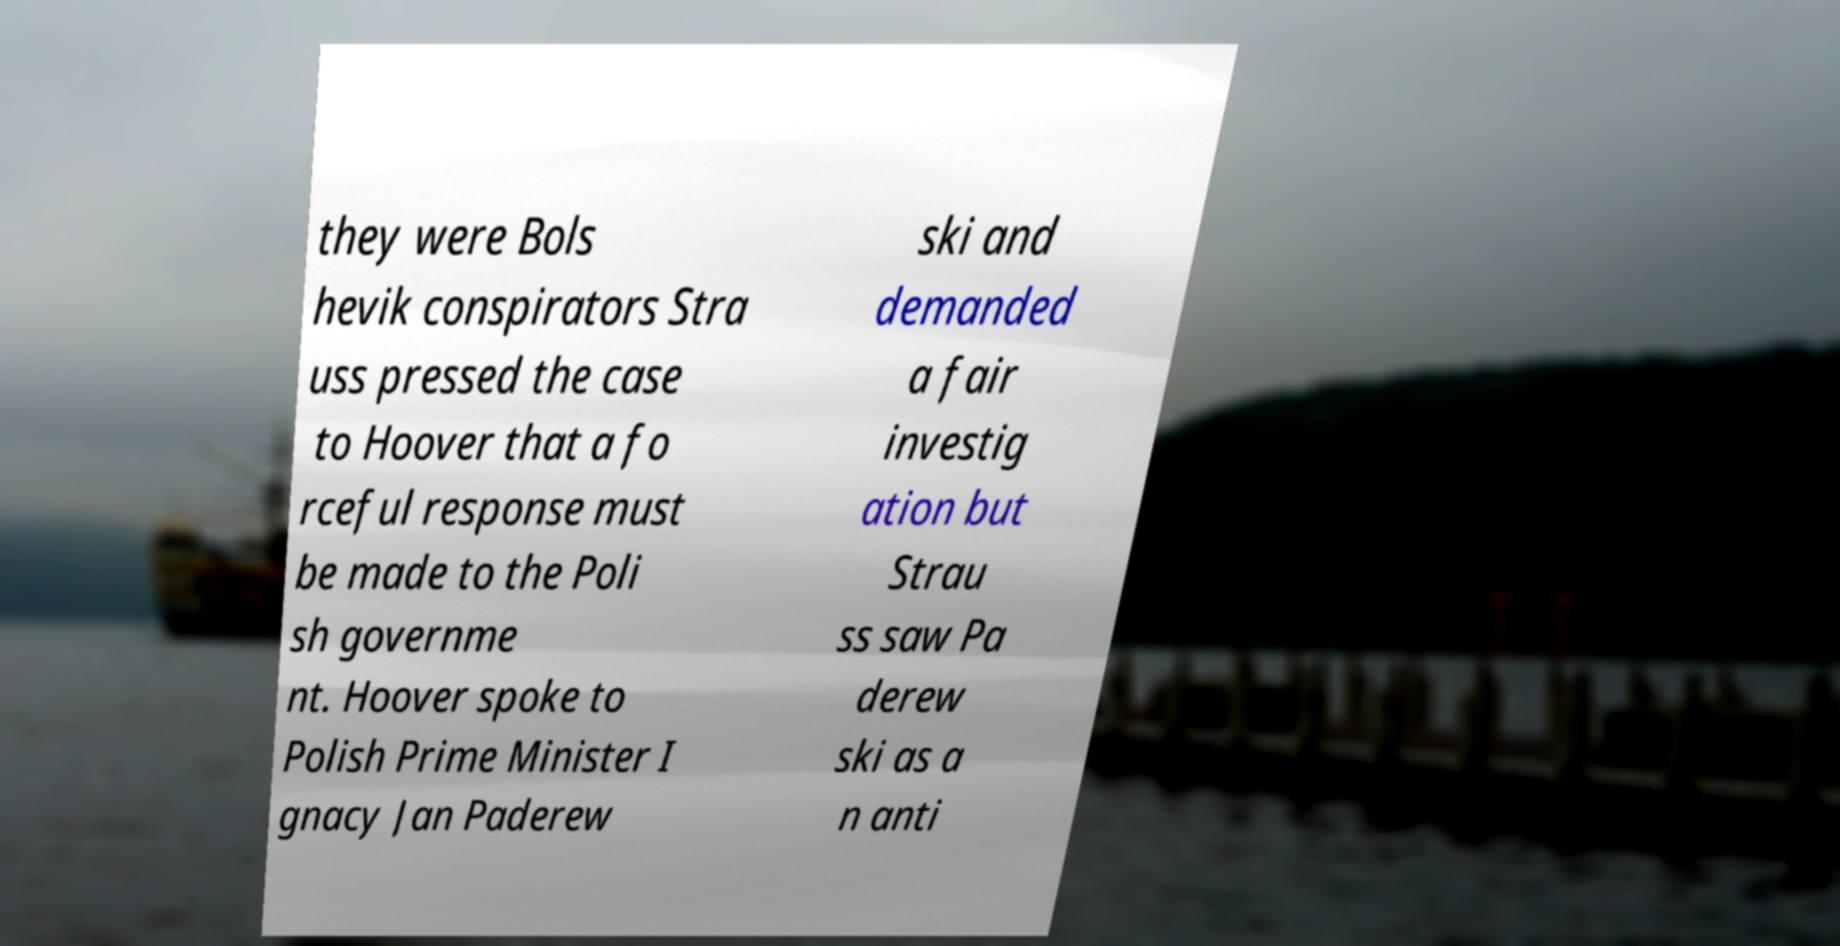Can you accurately transcribe the text from the provided image for me? they were Bols hevik conspirators Stra uss pressed the case to Hoover that a fo rceful response must be made to the Poli sh governme nt. Hoover spoke to Polish Prime Minister I gnacy Jan Paderew ski and demanded a fair investig ation but Strau ss saw Pa derew ski as a n anti 